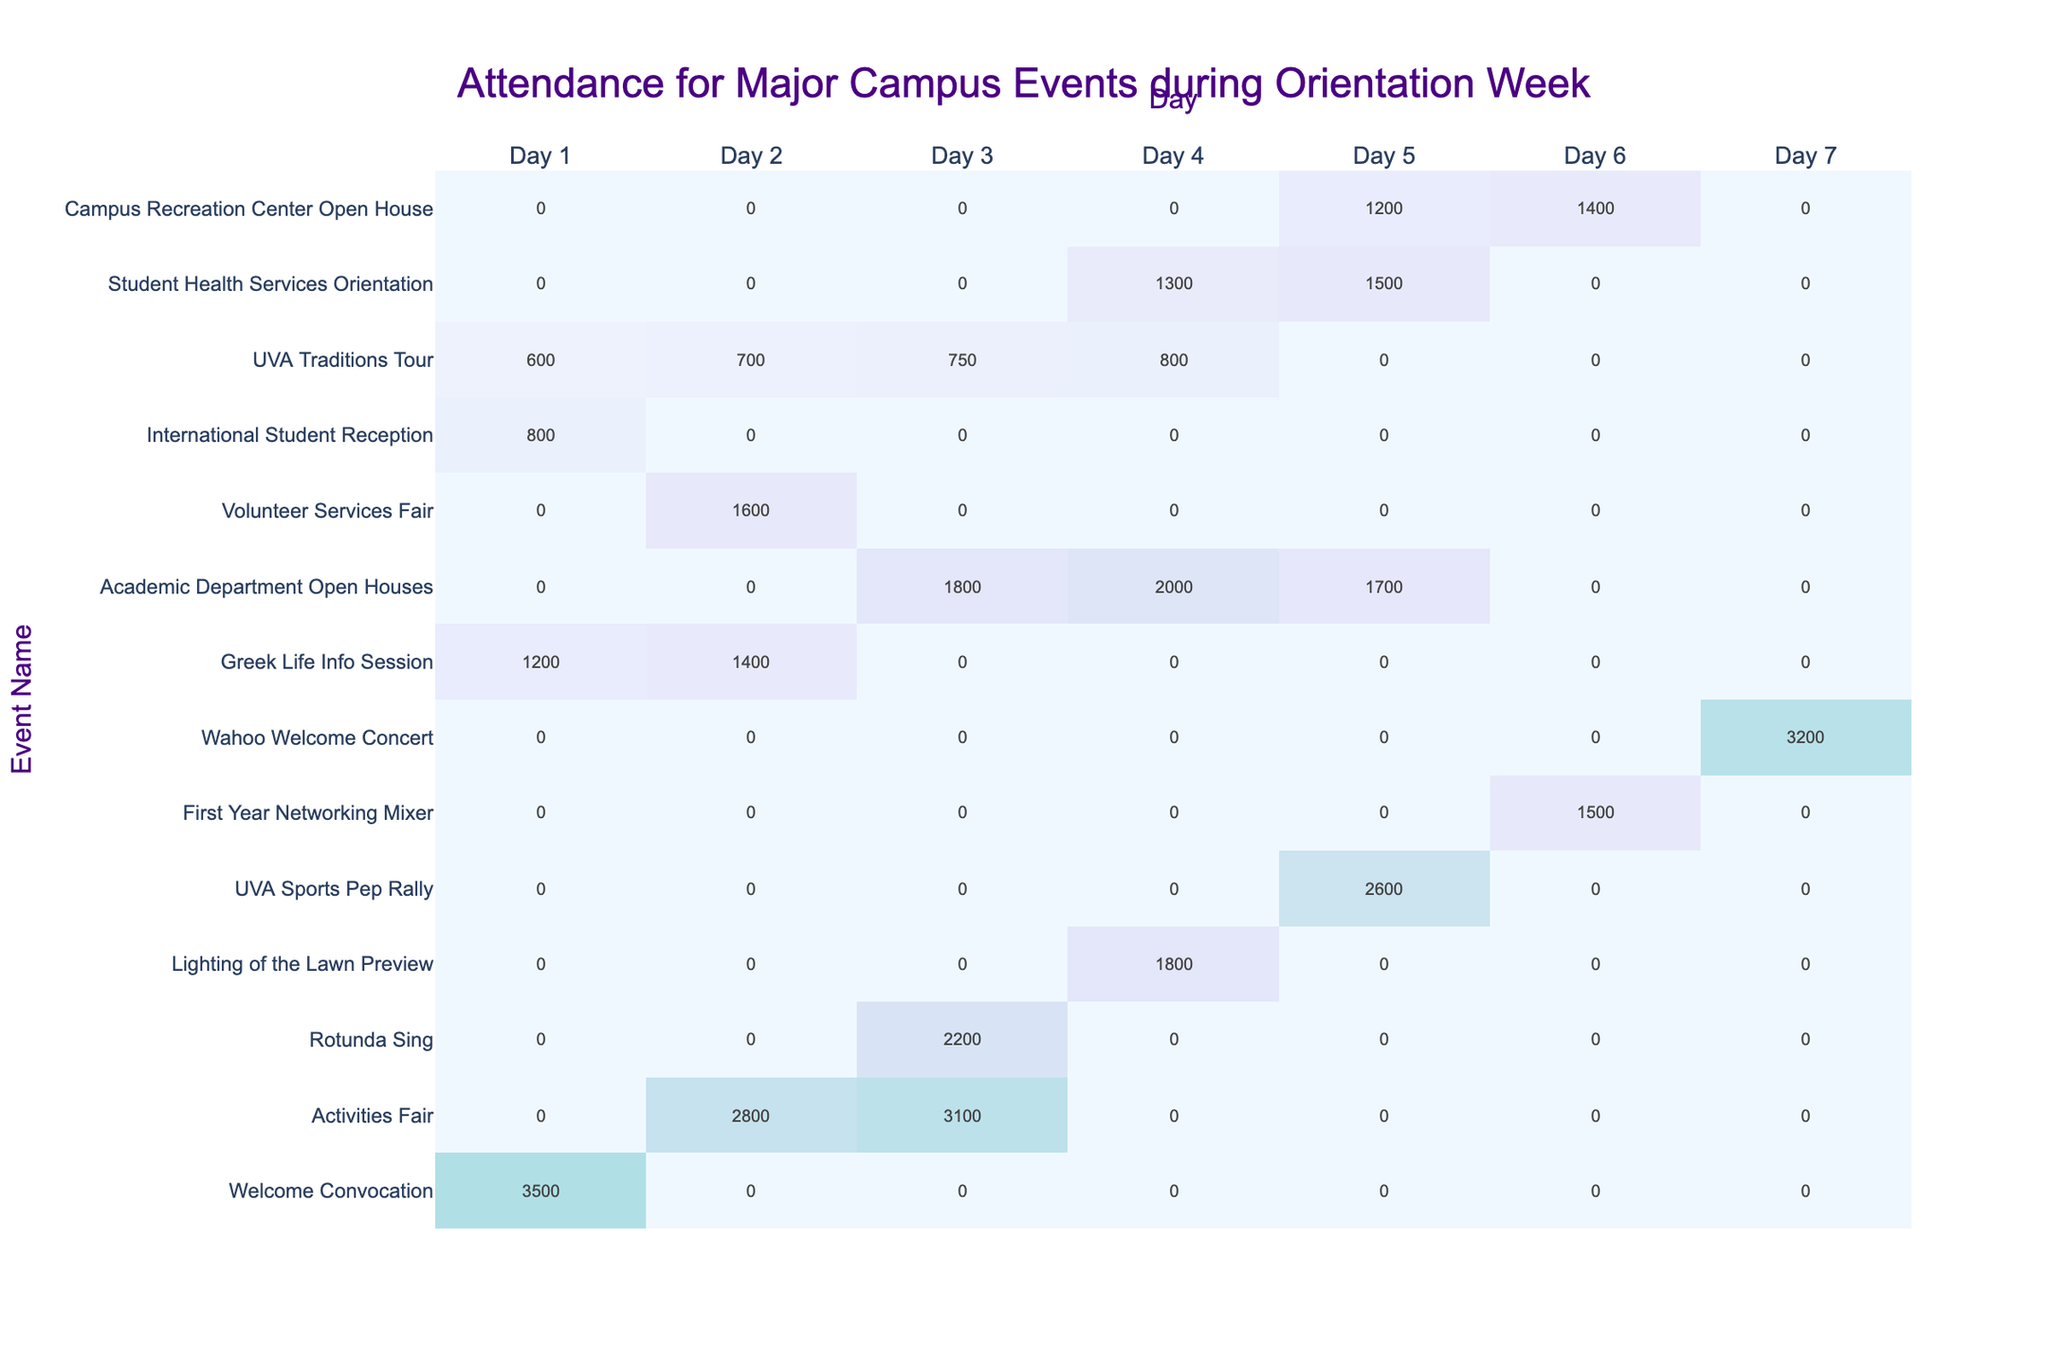What event had the highest attendance on Day 1? The highest attendance on Day 1 was 3500 for the Welcome Convocation. I can see this number listed next to that event in the respective column for Day 1.
Answer: 3500 Which day had the most events with attendance? Day 3 had the most events with attendance; there are three events listed with attendance numbers for that day (Rotunda Sing, Academic Department Open Houses, and Activities Fair).
Answer: Day 3 How many total attendees were there across all events on Day 4? To find the total on Day 4, I add up the attendance of all events: 1800 (Lighting of the Lawn Preview) + 1300 (Student Health Services Orientation) = 3100.
Answer: 3100 Did the Wahoo Welcome Concert have any attendees on the first six days? No, the Wahoo Welcome Concert had attendees only on Day 7, with 3200 total for that day.
Answer: No What is the average attendance for academic events (Academic Department Open Houses and Greek Life Info Session) over the seven days? The attendance for Academic Department Open Houses is 1800, 2000, and 1700, making a total of 5500. Greek Life Info Session has 1200, 1400 across two days, totaling 2600. Adding these gives 5500 + 2600 = 8100 for five days. Divided by 5 (the number of days with attendance), the average is 8100 / 5 = 1620.
Answer: 1620 Which event had the least attendance overall? The event with the least attendance is International Student Reception, which only had 800 attendees on Day 1. Looking across the entire table, this number is lower than any other event's total attendance.
Answer: 800 What is the total attendance for all events on Day 2? I sum the attendance numbers on Day 2: 2800 (Activities Fair) + 1600 (Volunteer Services Fair) + 1400 (Greek Life Info Session) = 5800.
Answer: 5800 On which day did the UVA Sports Pep Rally occur and what was its attendance? The UVA Sports Pep Rally occurred on Day 5 with an attendance of 2600. The information is found easily under the Day 5 column next to the event name.
Answer: Day 5, 2600 What was the difference in attendance between the highest and lowest attended event throughout the week? The highest attended event is the Welcome Convocation with 3500, and the lowest is the International Student Reception with 800. The difference is 3500 - 800 = 2700.
Answer: 2700 